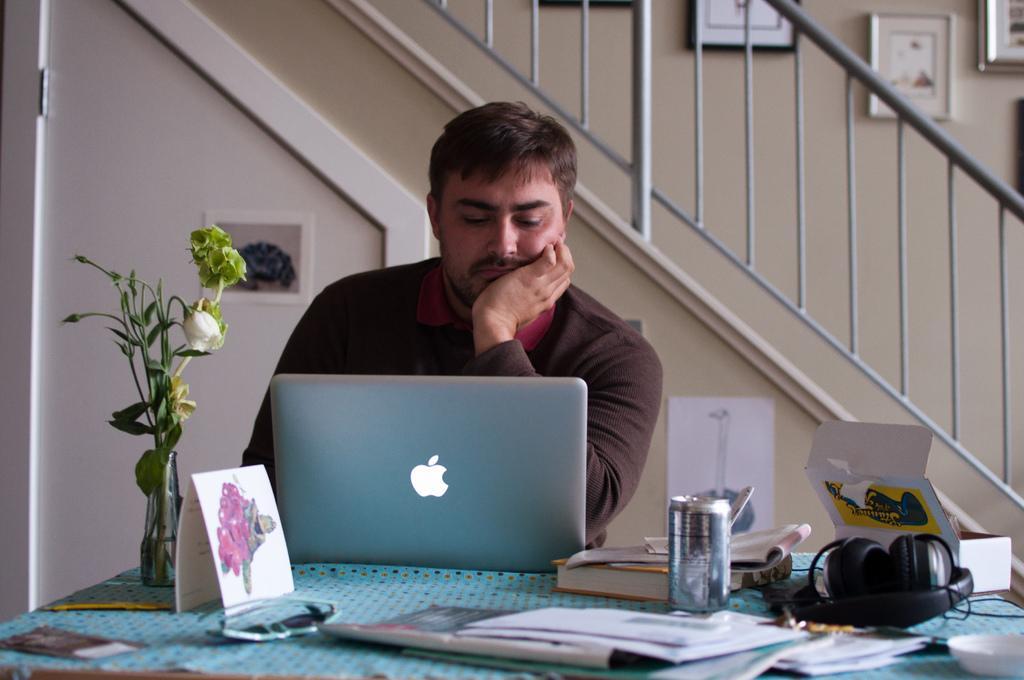Can you describe this image briefly? As we can see in the image there is a white color wall, stairs, photo frame, chair, a man sitting over here and a table. On table there is a laptop, flask, papers, headset and tin. 